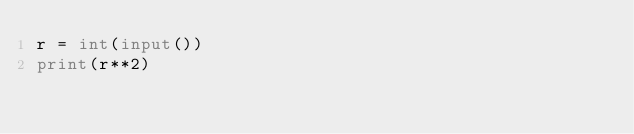<code> <loc_0><loc_0><loc_500><loc_500><_Python_>r = int(input())
print(r**2)</code> 